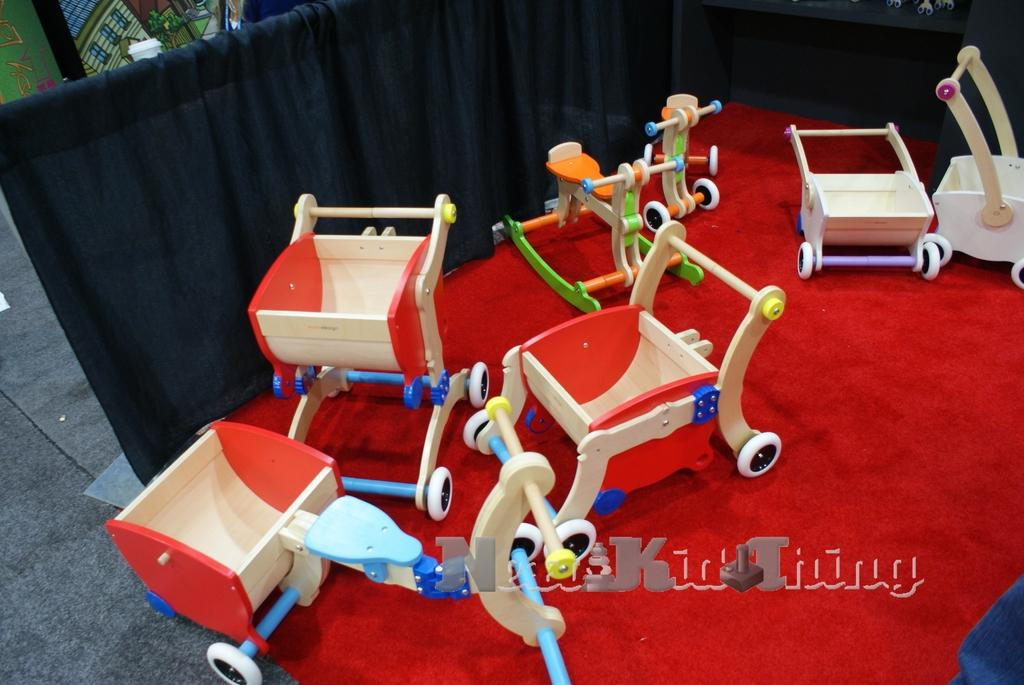What type of objects are in the image? There are toy vehicles in the image. What is the toy vehicles placed on? The toy vehicles are on a red color cloth. What type of background element can be seen in the image? There is a black color curtain in the image. What part of the room is visible in the image? The floor is visible in the image. Can you see a cat causing trouble with the toy vehicles in the image? There is no cat present in the image, and therefore no trouble with the toy vehicles can be observed. 